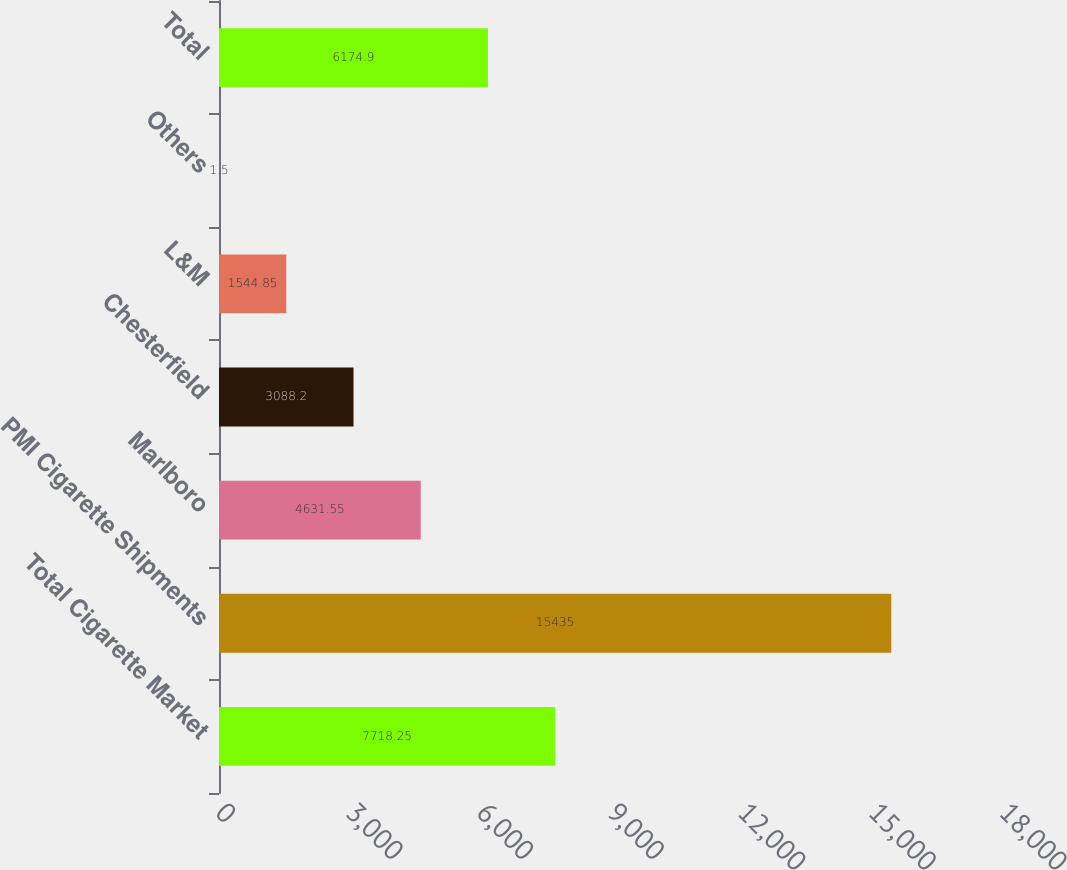Convert chart. <chart><loc_0><loc_0><loc_500><loc_500><bar_chart><fcel>Total Cigarette Market<fcel>PMI Cigarette Shipments<fcel>Marlboro<fcel>Chesterfield<fcel>L&M<fcel>Others<fcel>Total<nl><fcel>7718.25<fcel>15435<fcel>4631.55<fcel>3088.2<fcel>1544.85<fcel>1.5<fcel>6174.9<nl></chart> 